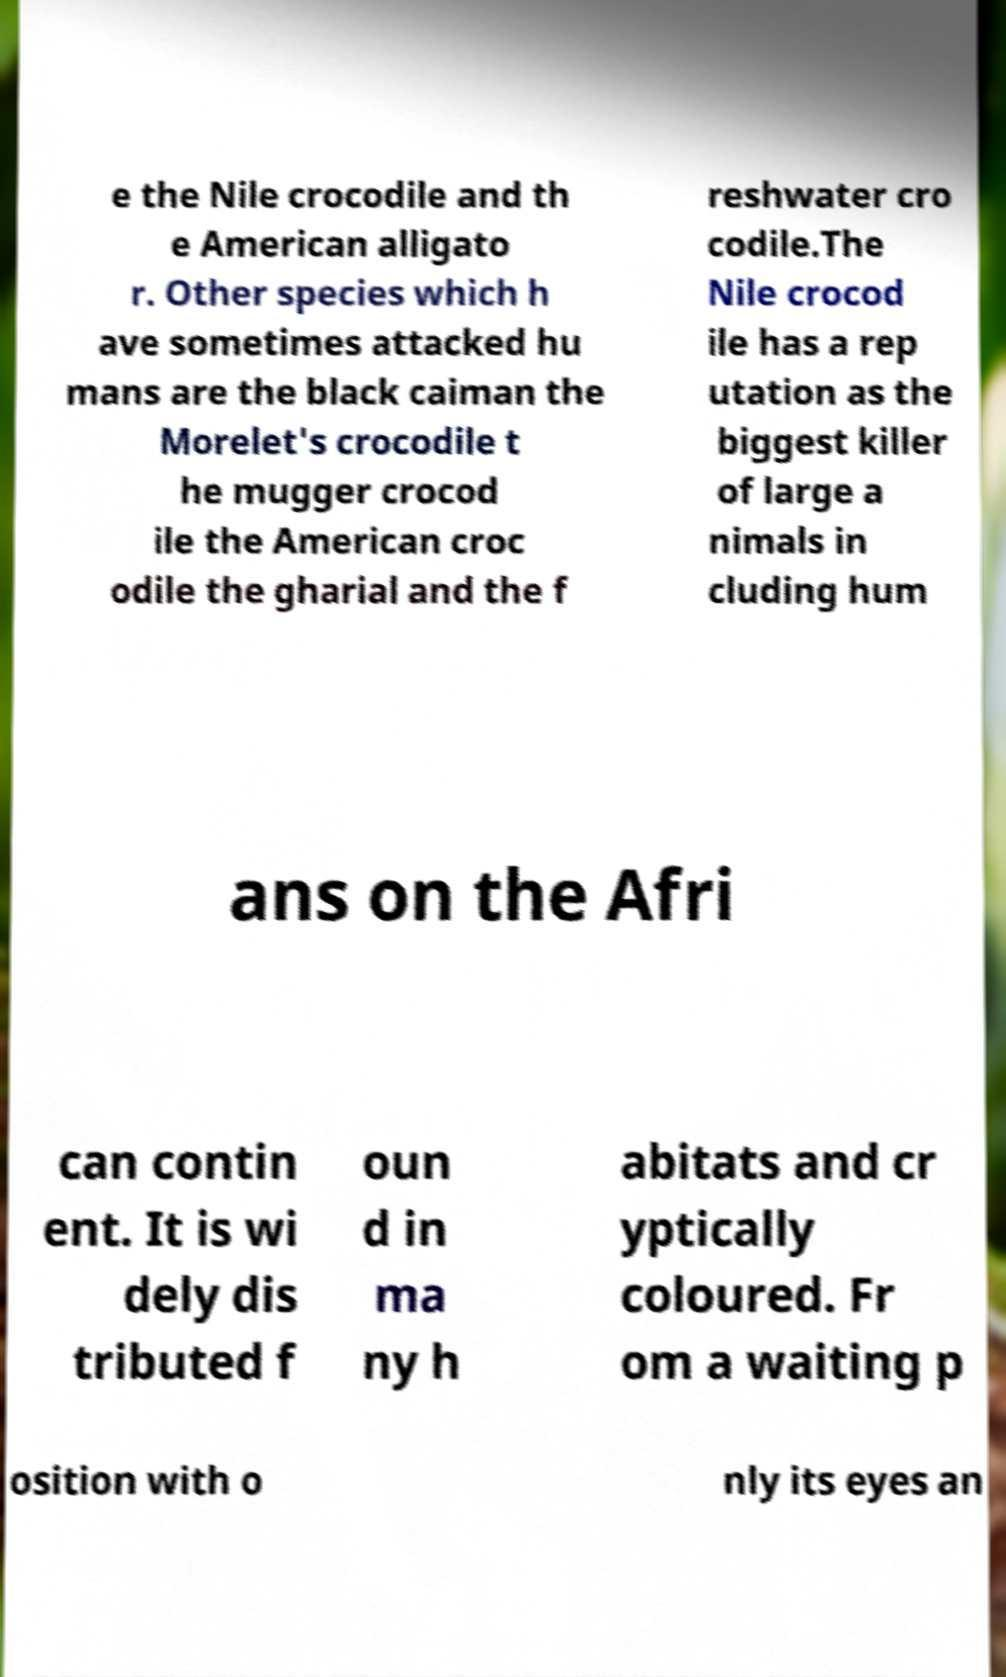I need the written content from this picture converted into text. Can you do that? e the Nile crocodile and th e American alligato r. Other species which h ave sometimes attacked hu mans are the black caiman the Morelet's crocodile t he mugger crocod ile the American croc odile the gharial and the f reshwater cro codile.The Nile crocod ile has a rep utation as the biggest killer of large a nimals in cluding hum ans on the Afri can contin ent. It is wi dely dis tributed f oun d in ma ny h abitats and cr yptically coloured. Fr om a waiting p osition with o nly its eyes an 